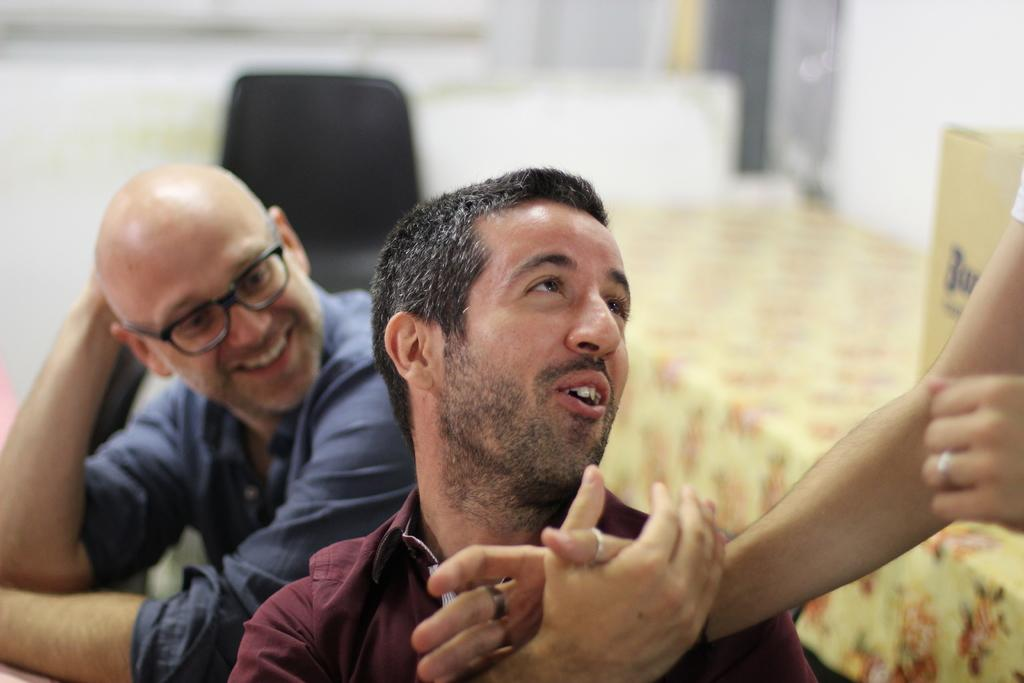How many people are present in the image? There are three people in the image. What furniture can be seen in the image? There is a chair and a table in the image. What is covering the table? There is a cover on top of the table. How would you describe the background of the image? The background of the image is blurred. What action are the chairs performing in the image? There are no actions being performed by chairs in the image, as chairs are inanimate objects. 